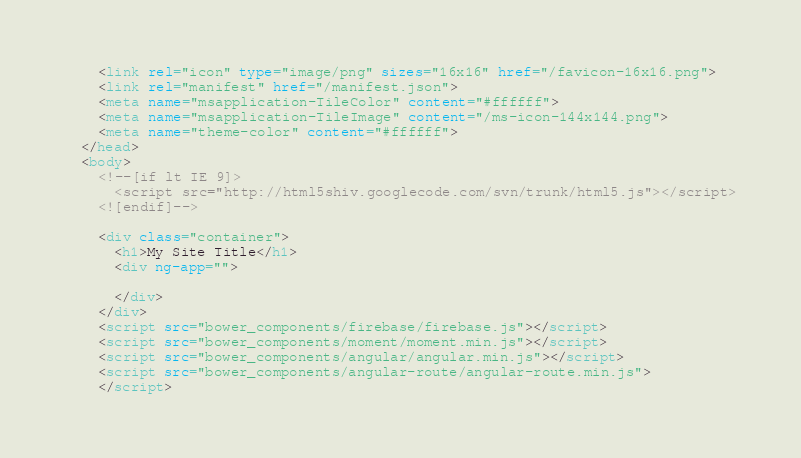Convert code to text. <code><loc_0><loc_0><loc_500><loc_500><_HTML_>    <link rel="icon" type="image/png" sizes="16x16" href="/favicon-16x16.png">
    <link rel="manifest" href="/manifest.json">
    <meta name="msapplication-TileColor" content="#ffffff">
    <meta name="msapplication-TileImage" content="/ms-icon-144x144.png">
    <meta name="theme-color" content="#ffffff">
  </head>
  <body>
    <!--[if lt IE 9]>
      <script src="http://html5shiv.googlecode.com/svn/trunk/html5.js"></script>
    <![endif]-->

    <div class="container">
      <h1>My Site Title</h1>
      <div ng-app="">

      </div>
    </div>
    <script src="bower_components/firebase/firebase.js"></script>
    <script src="bower_components/moment/moment.min.js"></script>
    <script src="bower_components/angular/angular.min.js"></script>
    <script src="bower_components/angular-route/angular-route.min.js">
    </script></code> 